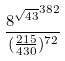<formula> <loc_0><loc_0><loc_500><loc_500>\frac { { 8 ^ { \sqrt { 4 3 } } } ^ { 3 8 2 } } { ( \frac { 2 1 5 } { 4 3 0 } ) ^ { 7 2 } }</formula> 